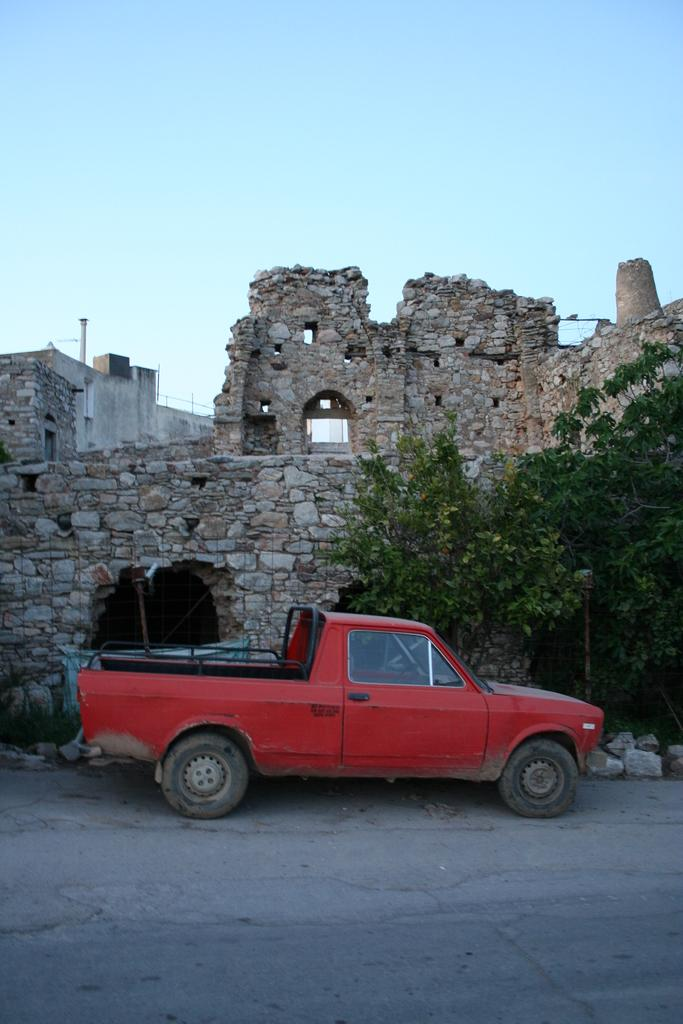What is the main structure in the image? There is a monument in the image. What else can be seen in the image besides the monument? There are buildings, trees, and a mini truck in the image. What is the color of the sky in the image? The sky is blue in the image. Can you tell me how many cannons are placed near the river in the image? There is no river or cannons present in the image. What type of design is featured on the monument in the image? The provided facts do not mention any specific design on the monument, so we cannot answer this question. 